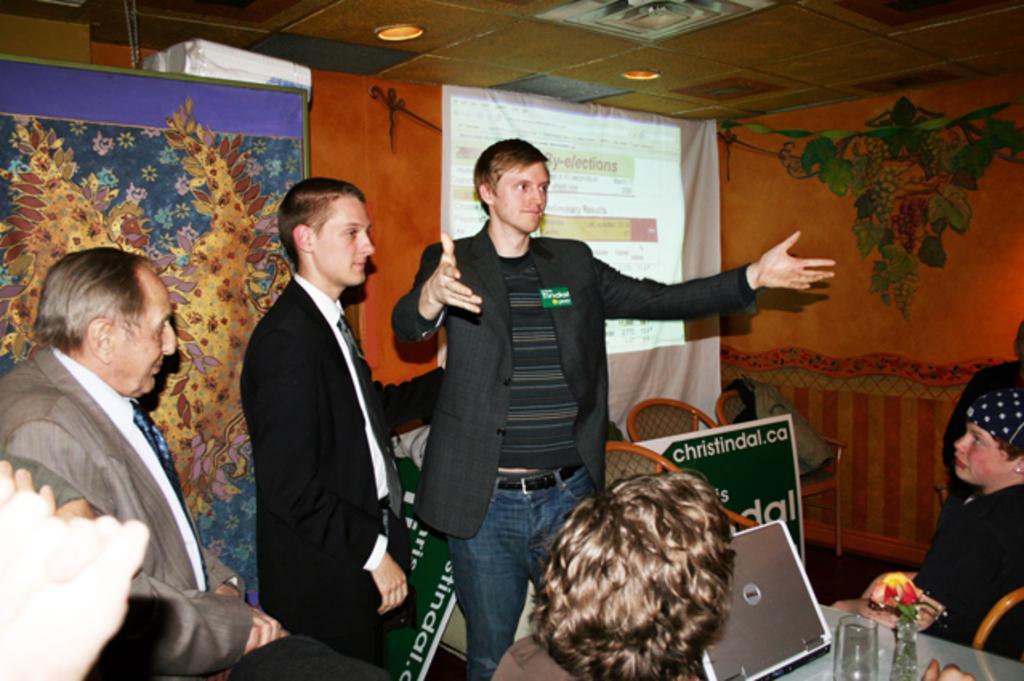Can you describe this image briefly? In this picture, we can see a few people, and we can see table and some objects on the table, like bottles, glass, and we can see chairs, posters with some text on it, we can see the wall with some design, and some objects attached to it, we can see screen and the roof with lights. 